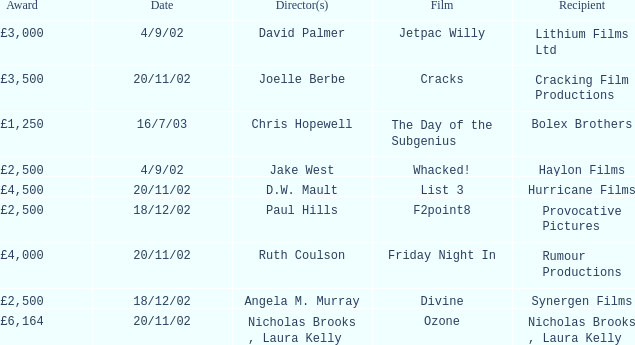Who earned a £3,000 prize on the 9th of april, 2002? Lithium Films Ltd. 